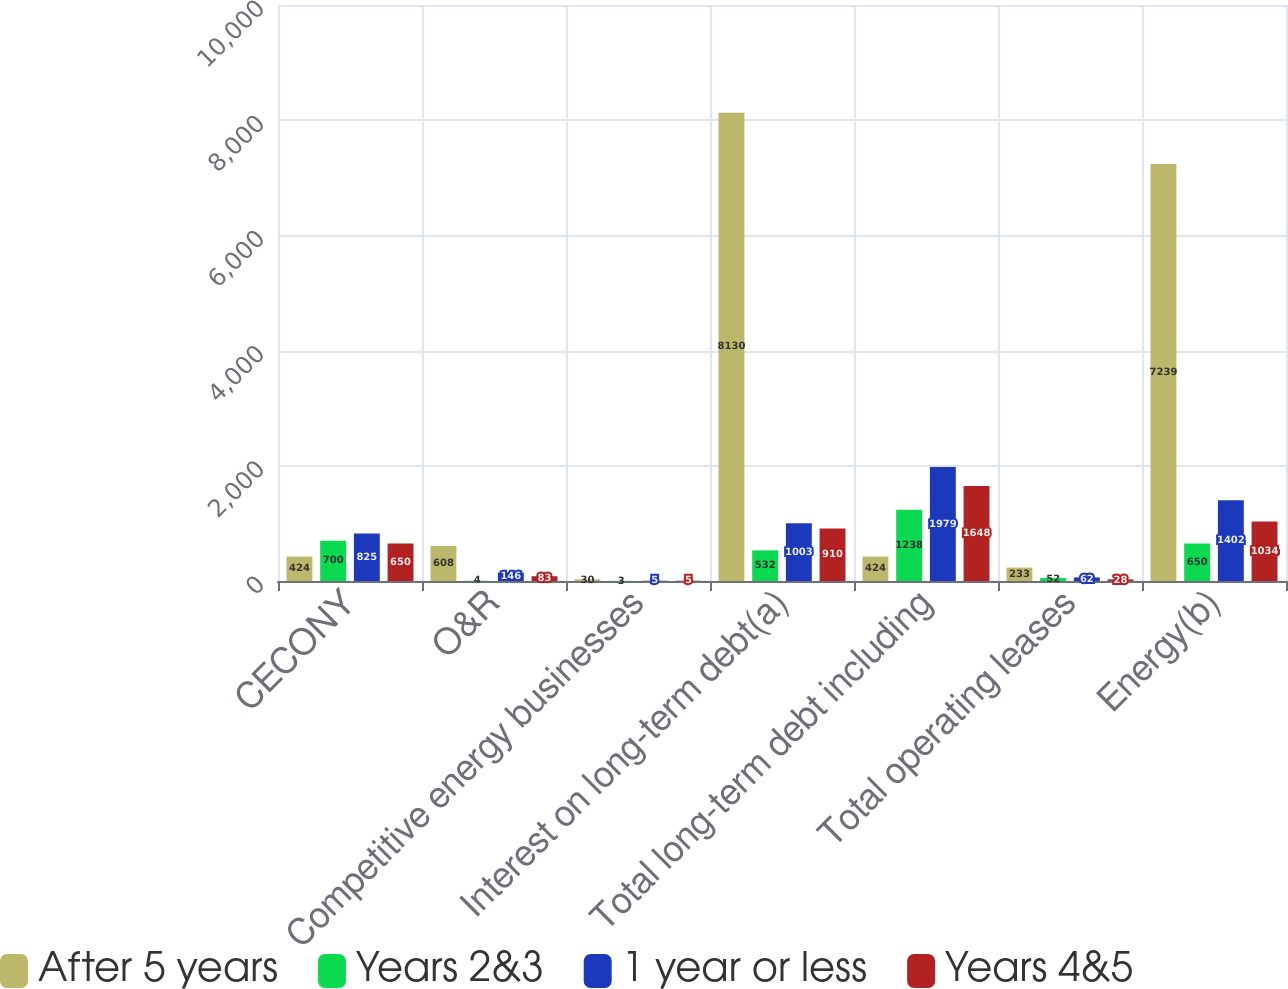Convert chart to OTSL. <chart><loc_0><loc_0><loc_500><loc_500><stacked_bar_chart><ecel><fcel>CECONY<fcel>O&R<fcel>Competitive energy businesses<fcel>Interest on long-term debt(a)<fcel>Total long-term debt including<fcel>Total operating leases<fcel>Energy(b)<nl><fcel>After 5 years<fcel>424<fcel>608<fcel>30<fcel>8130<fcel>424<fcel>233<fcel>7239<nl><fcel>Years 2&3<fcel>700<fcel>4<fcel>3<fcel>532<fcel>1238<fcel>52<fcel>650<nl><fcel>1 year or less<fcel>825<fcel>146<fcel>5<fcel>1003<fcel>1979<fcel>62<fcel>1402<nl><fcel>Years 4&5<fcel>650<fcel>83<fcel>5<fcel>910<fcel>1648<fcel>28<fcel>1034<nl></chart> 